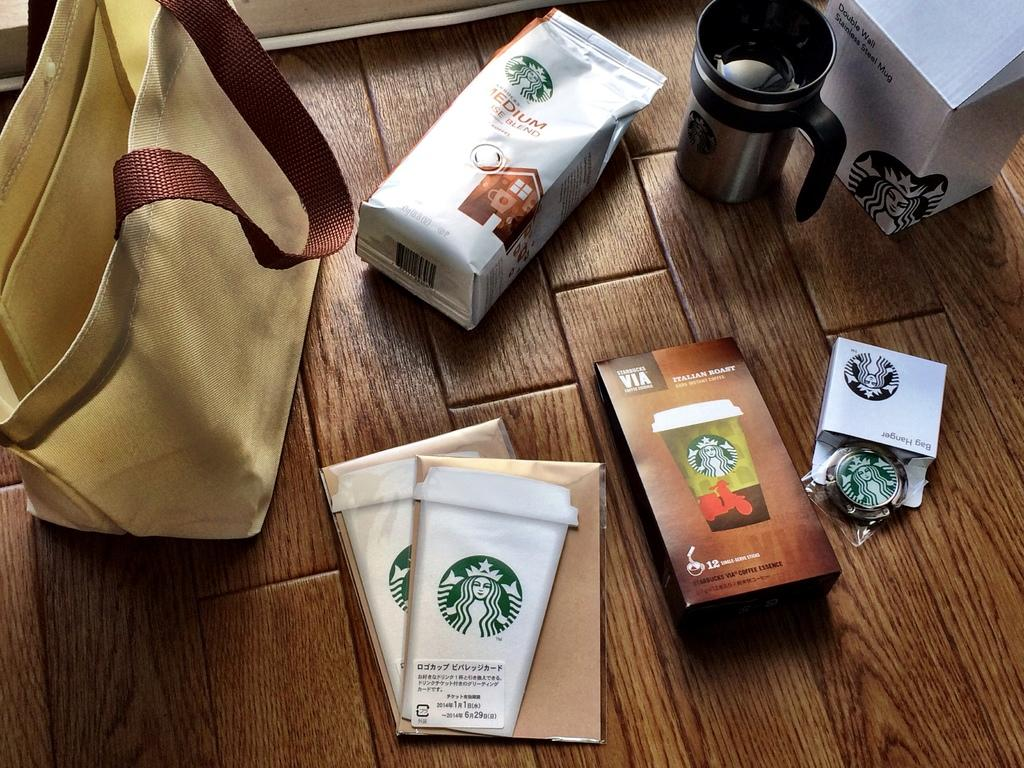What is one of the objects visible in the image? There is a bag in the image. What else can be seen in the image besides the bag? There is a book and a box in the image. Are there any other objects on the floor in the image? Yes, there are other objects on the floor in the image. How many bulbs are hanging from the ceiling in the image? There is no information about any bulbs in the image, as the facts only mention objects on the floor. 